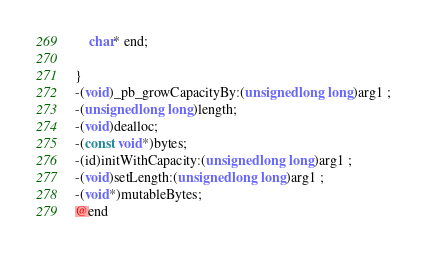Convert code to text. <code><loc_0><loc_0><loc_500><loc_500><_C_>	char* end;

}
-(void)_pb_growCapacityBy:(unsigned long long)arg1 ;
-(unsigned long long)length;
-(void)dealloc;
-(const void*)bytes;
-(id)initWithCapacity:(unsigned long long)arg1 ;
-(void)setLength:(unsigned long long)arg1 ;
-(void*)mutableBytes;
@end

</code> 